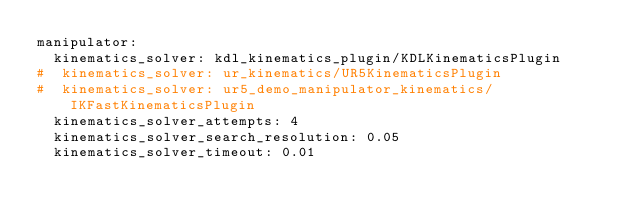Convert code to text. <code><loc_0><loc_0><loc_500><loc_500><_YAML_>manipulator:
  kinematics_solver: kdl_kinematics_plugin/KDLKinematicsPlugin
#  kinematics_solver: ur_kinematics/UR5KinematicsPlugin
#  kinematics_solver: ur5_demo_manipulator_kinematics/IKFastKinematicsPlugin
  kinematics_solver_attempts: 4
  kinematics_solver_search_resolution: 0.05
  kinematics_solver_timeout: 0.01
</code> 